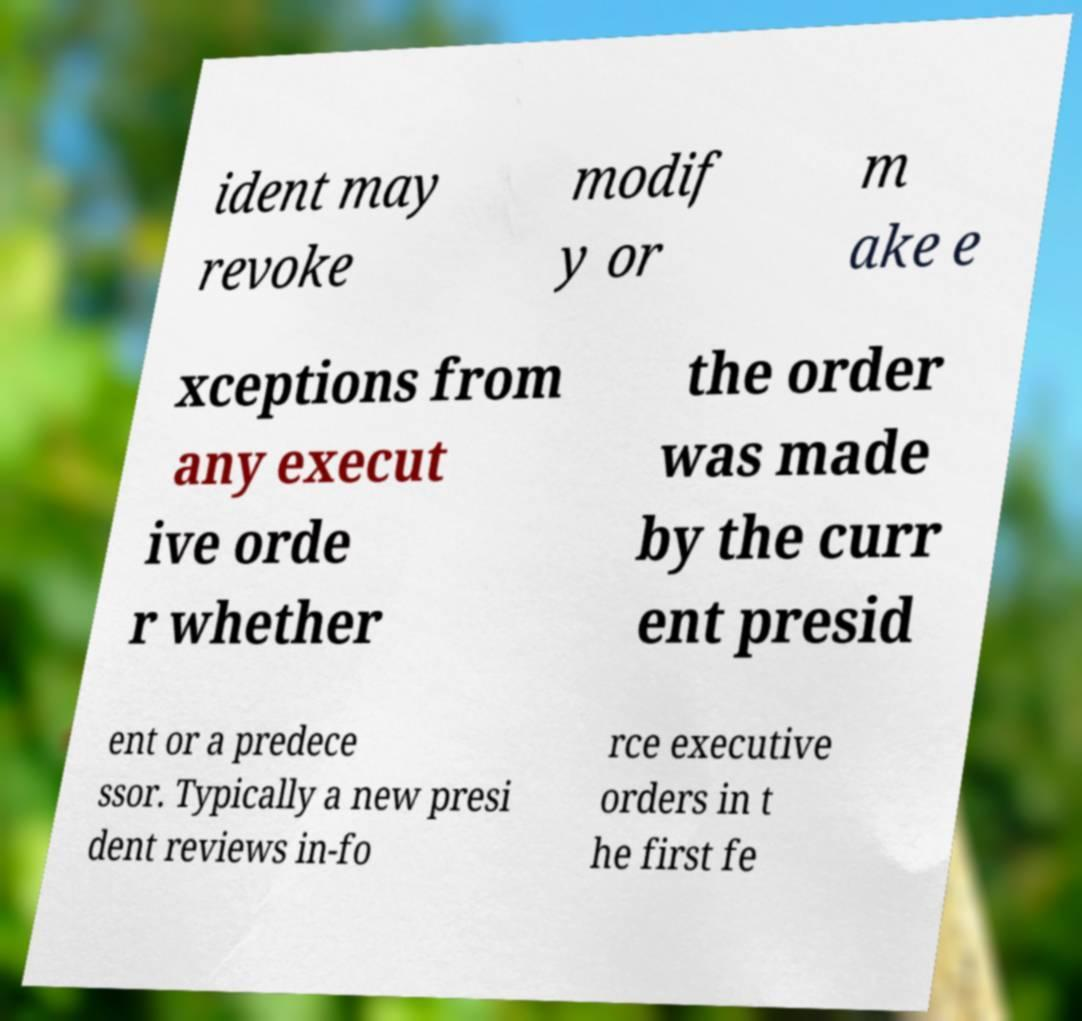I need the written content from this picture converted into text. Can you do that? ident may revoke modif y or m ake e xceptions from any execut ive orde r whether the order was made by the curr ent presid ent or a predece ssor. Typically a new presi dent reviews in-fo rce executive orders in t he first fe 